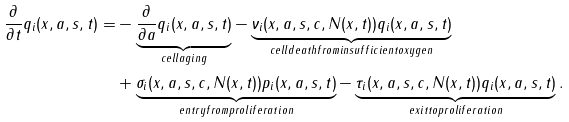Convert formula to latex. <formula><loc_0><loc_0><loc_500><loc_500>\frac { \partial } { \partial t } q _ { i } ( x , a , s , t ) = & - \underbrace { \frac { \partial } { \partial a } q _ { i } ( x , a , s , t ) } _ { c e l l a g i n g } - \underbrace { \nu _ { i } ( x , a , s , c , N ( x , t ) ) q _ { i } ( x , a , s , t ) } _ { c e l l d e a t h f r o m i n s u f f i c i e n t o x y g e n } \\ & + \underbrace { \sigma _ { i } ( x , a , s , c , N ( x , t ) ) p _ { i } ( x , a , s , t ) } _ { e n t r y f r o m p r o l i f e r a t i o n } - \underbrace { \tau _ { i } ( x , a , s , c , N ( x , t ) ) q _ { i } ( x , a , s , t ) } _ { e x i t t o p r o l i f e r a t i o n } .</formula> 